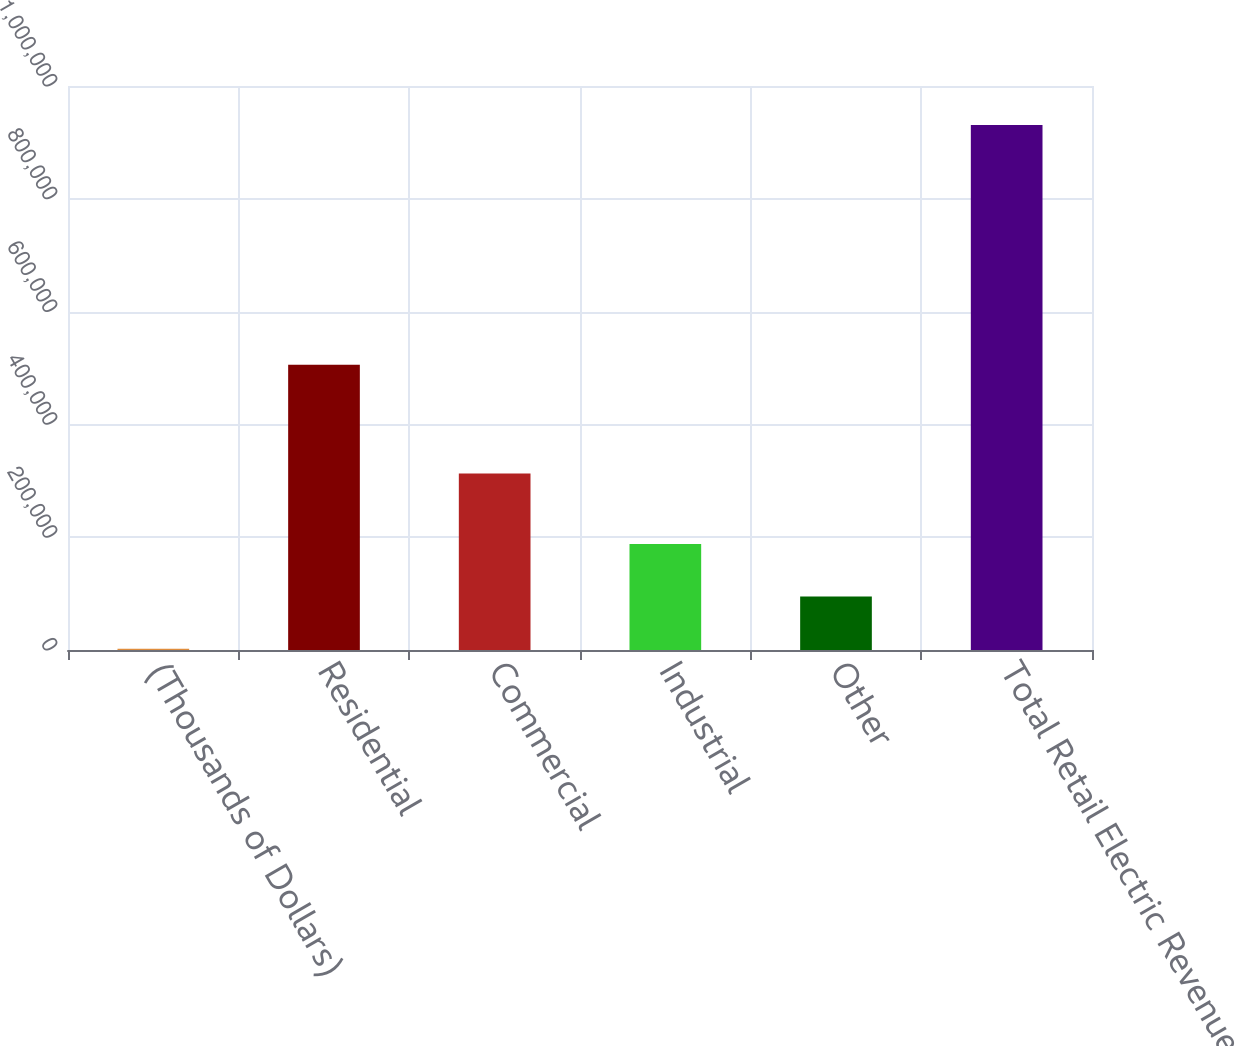Convert chart to OTSL. <chart><loc_0><loc_0><loc_500><loc_500><bar_chart><fcel>(Thousands of Dollars)<fcel>Residential<fcel>Commercial<fcel>Industrial<fcel>Other<fcel>Total Retail Electric Revenues<nl><fcel>2015<fcel>505806<fcel>312918<fcel>187760<fcel>94887.6<fcel>930741<nl></chart> 